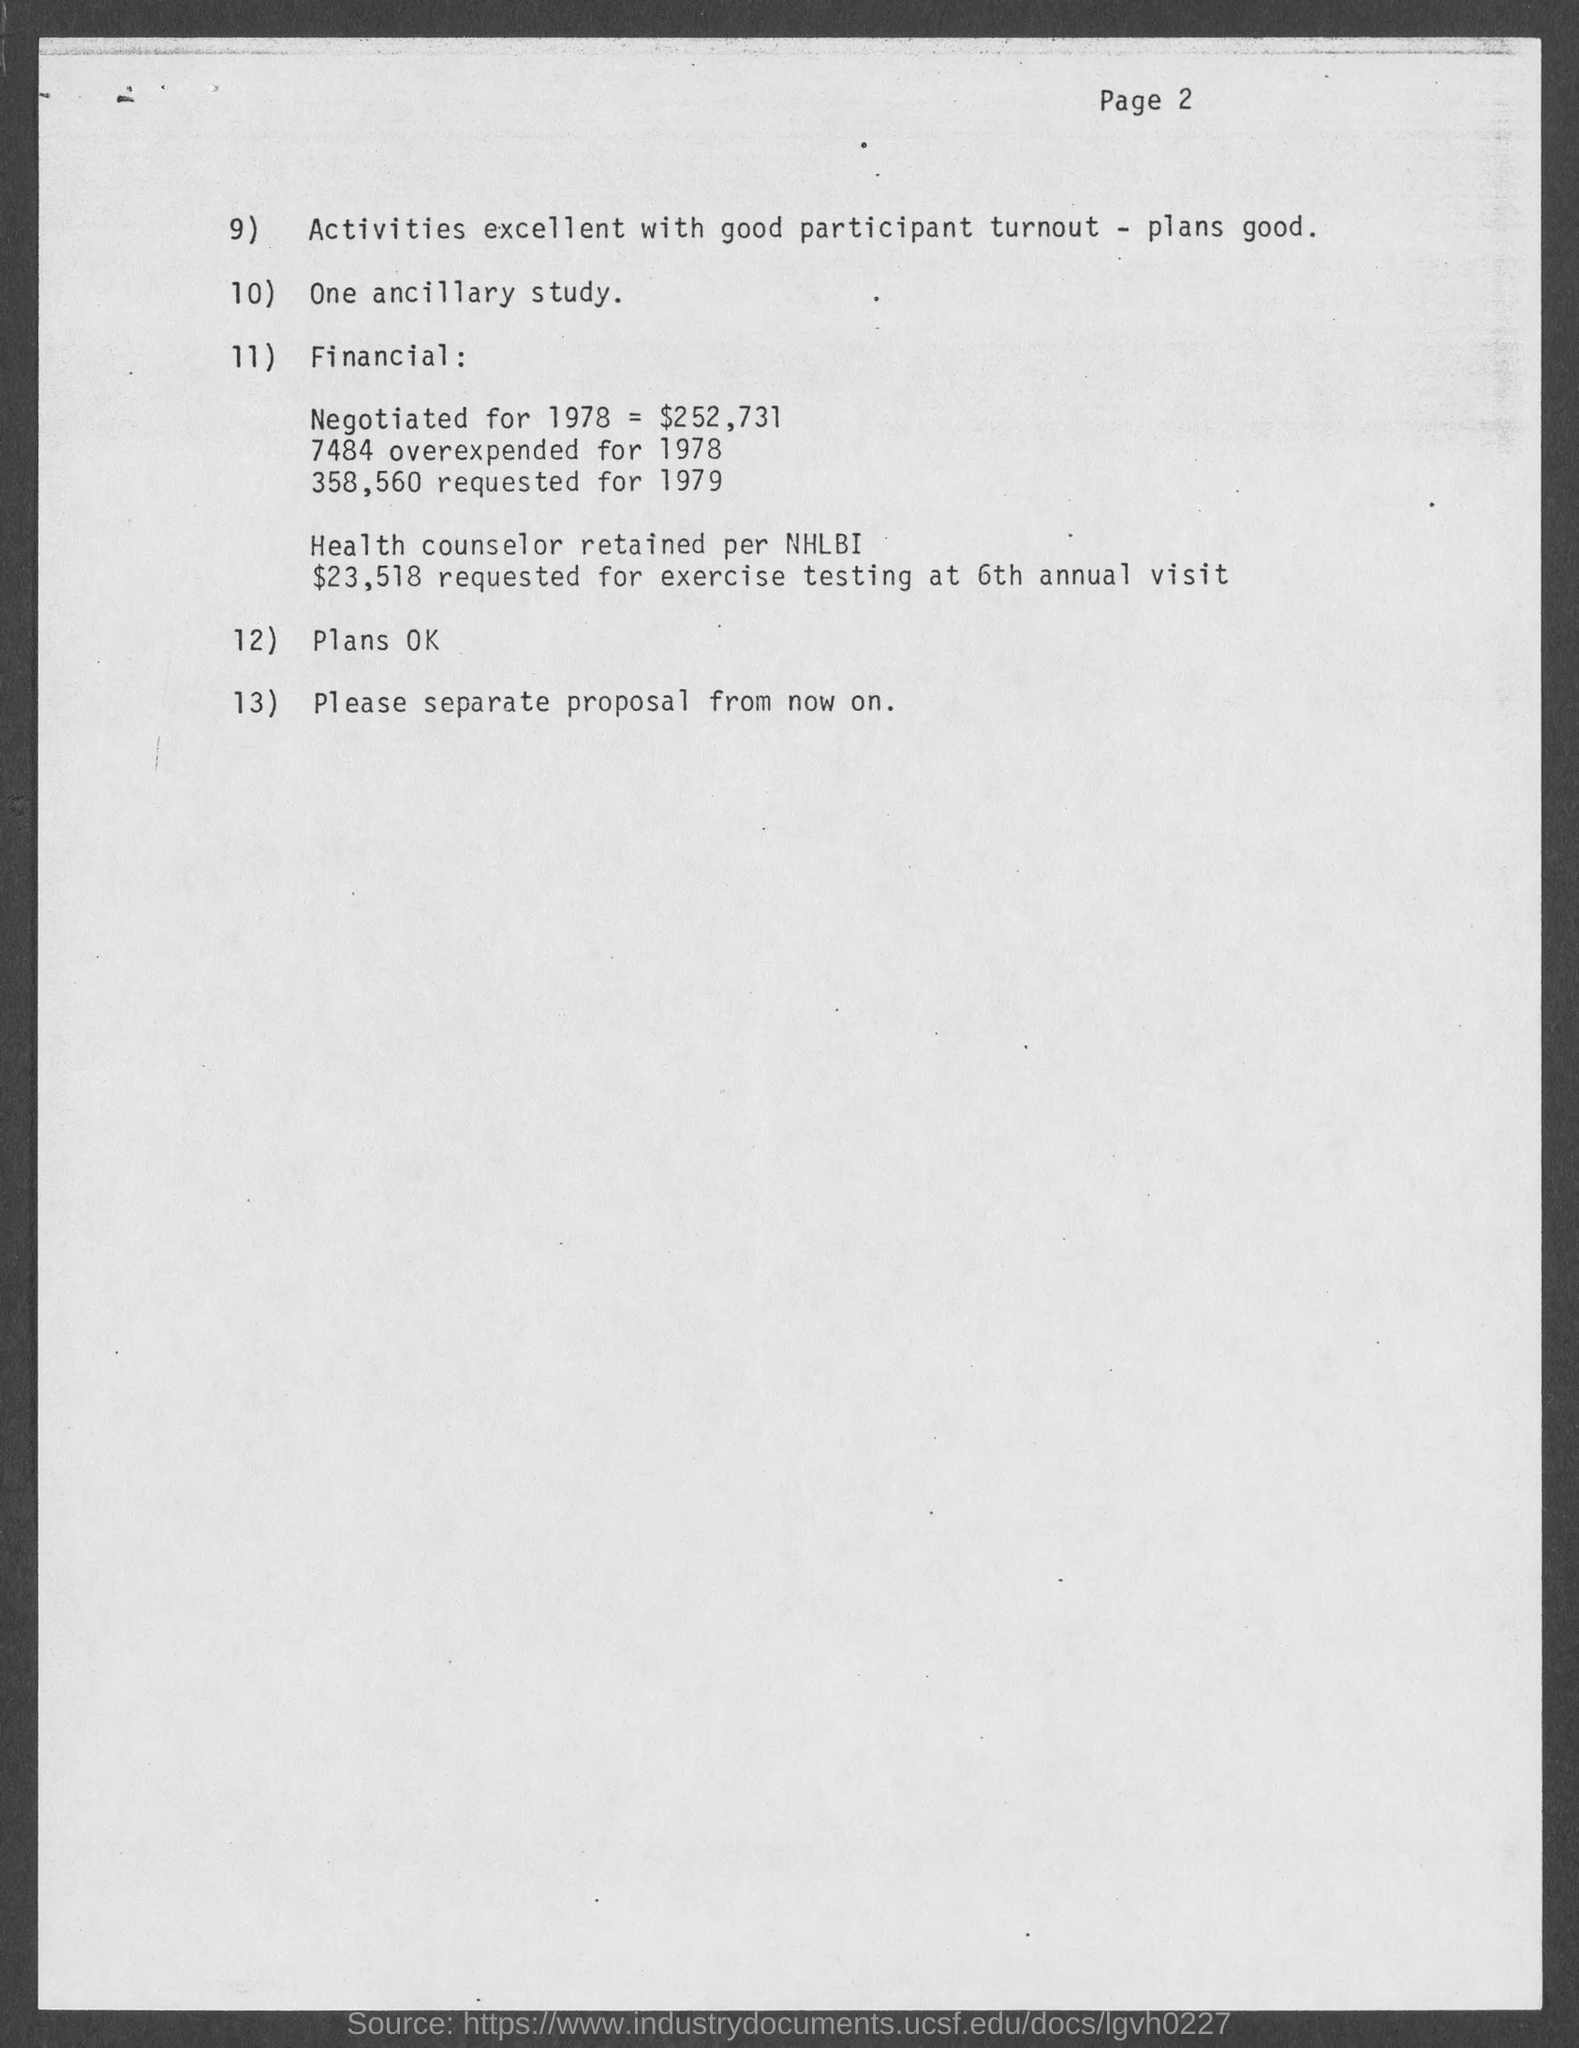What is the page number at top of the page?
Your answer should be compact. 2. 